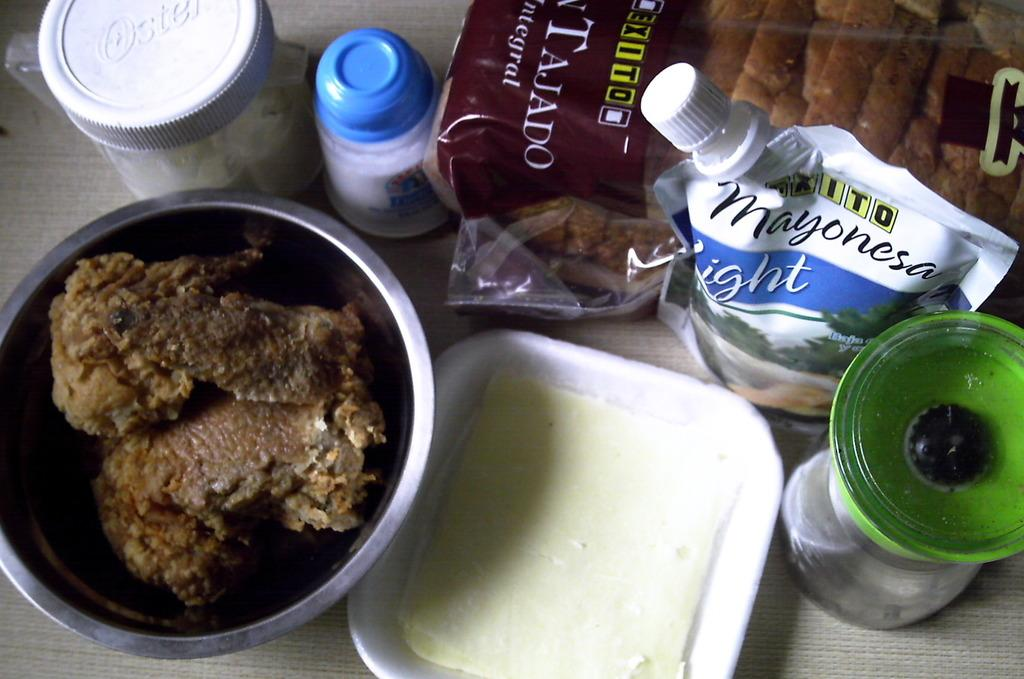<image>
Offer a succinct explanation of the picture presented. Different food items including bread and mayo sit on a table. 